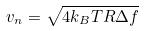Convert formula to latex. <formula><loc_0><loc_0><loc_500><loc_500>v _ { n } = \sqrt { 4 k _ { B } T R \Delta f }</formula> 